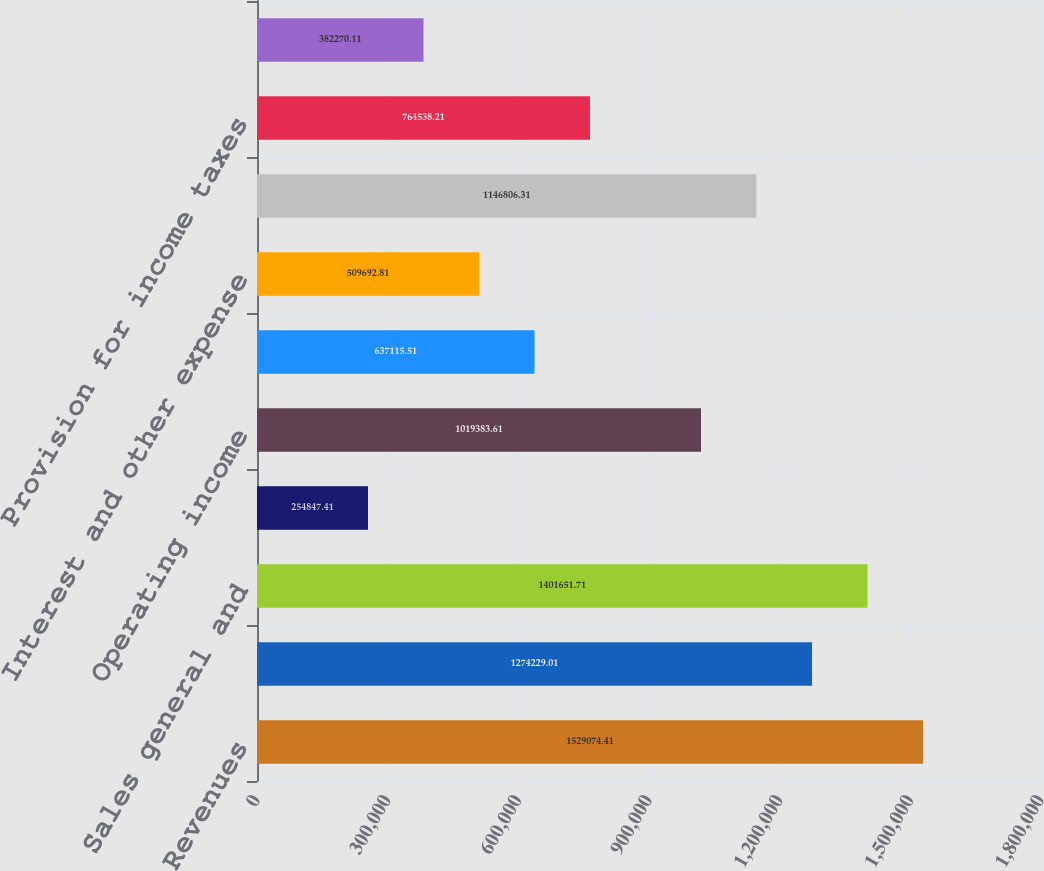<chart> <loc_0><loc_0><loc_500><loc_500><bar_chart><fcel>Revenues<fcel>Cost of service<fcel>Sales general and<fcel>Restructuring and other<fcel>Operating income<fcel>Interest and other income<fcel>Interest and other expense<fcel>Income before income taxes and<fcel>Provision for income taxes<fcel>Minority interest net of tax<nl><fcel>1.52907e+06<fcel>1.27423e+06<fcel>1.40165e+06<fcel>254847<fcel>1.01938e+06<fcel>637116<fcel>509693<fcel>1.14681e+06<fcel>764538<fcel>382270<nl></chart> 